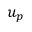<formula> <loc_0><loc_0><loc_500><loc_500>u _ { p }</formula> 